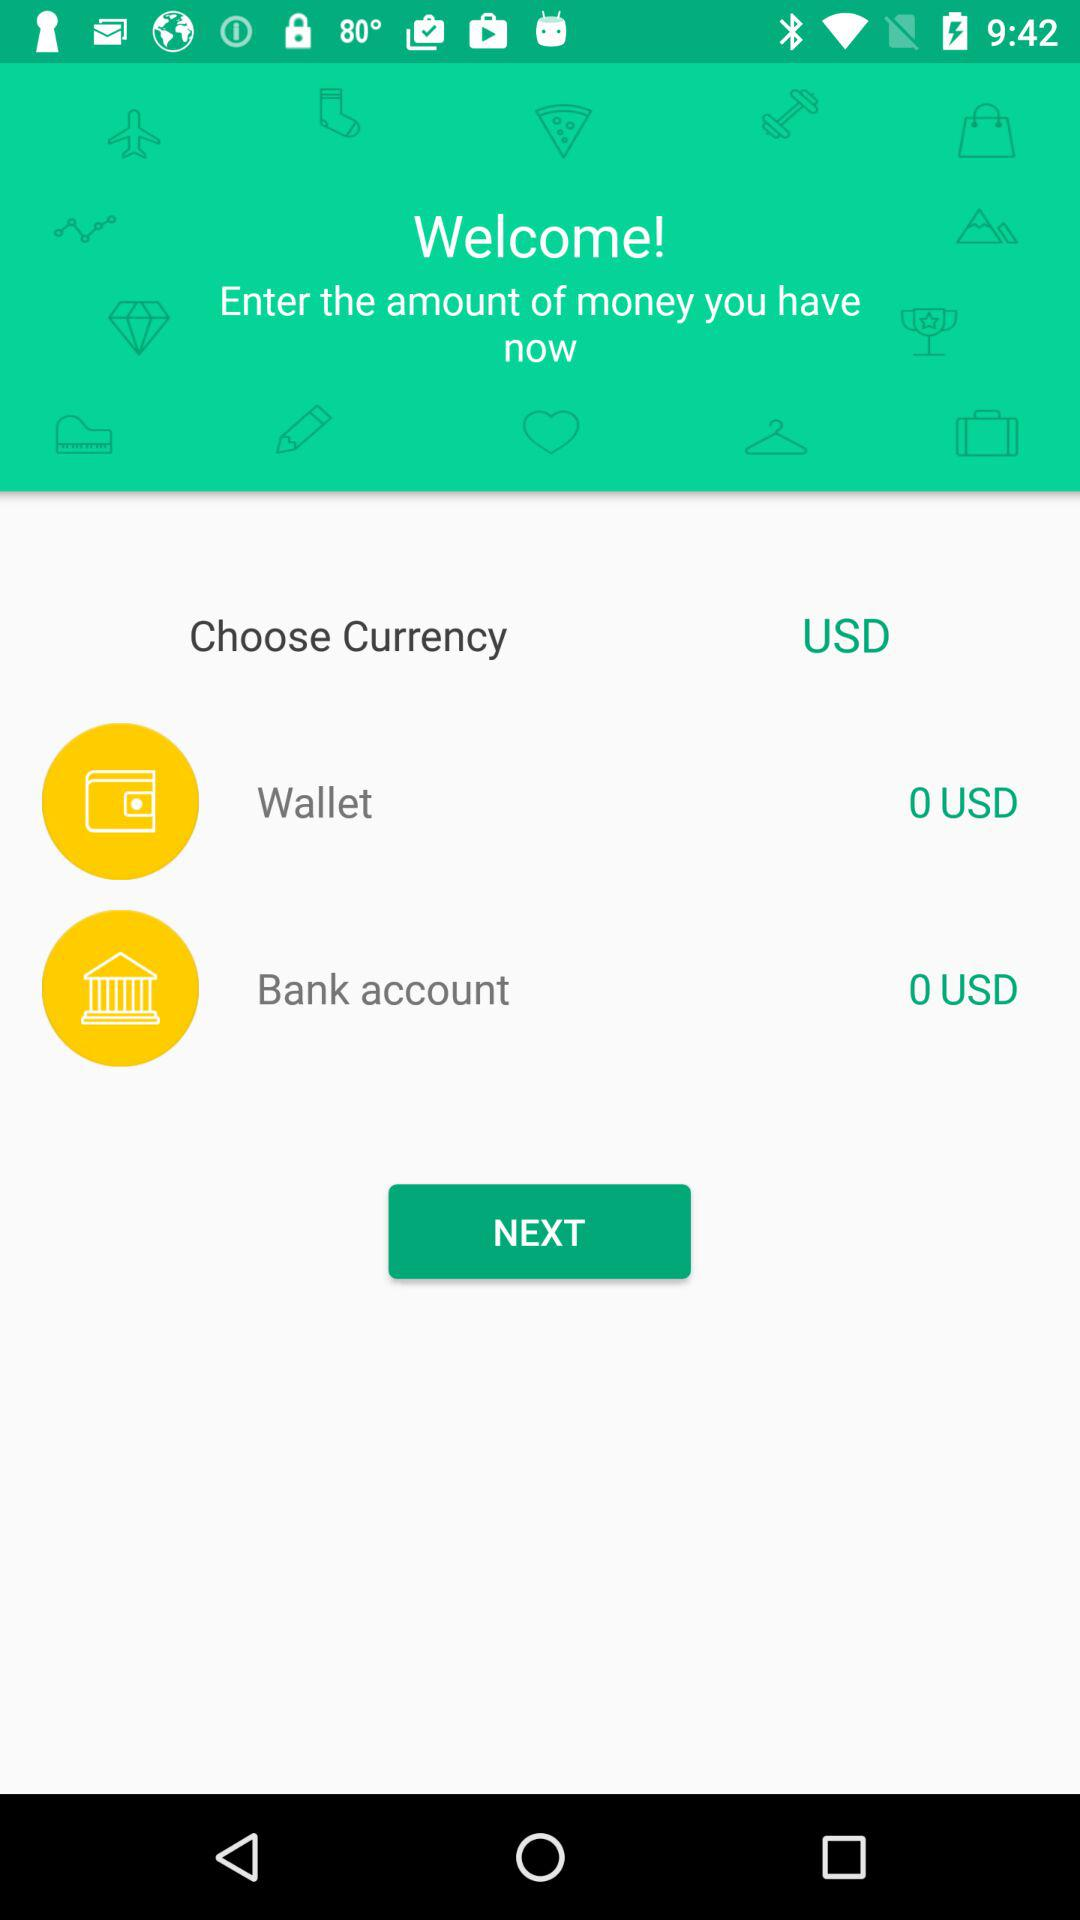How much money is in the wallet? There is 0 USD in the wallet. 